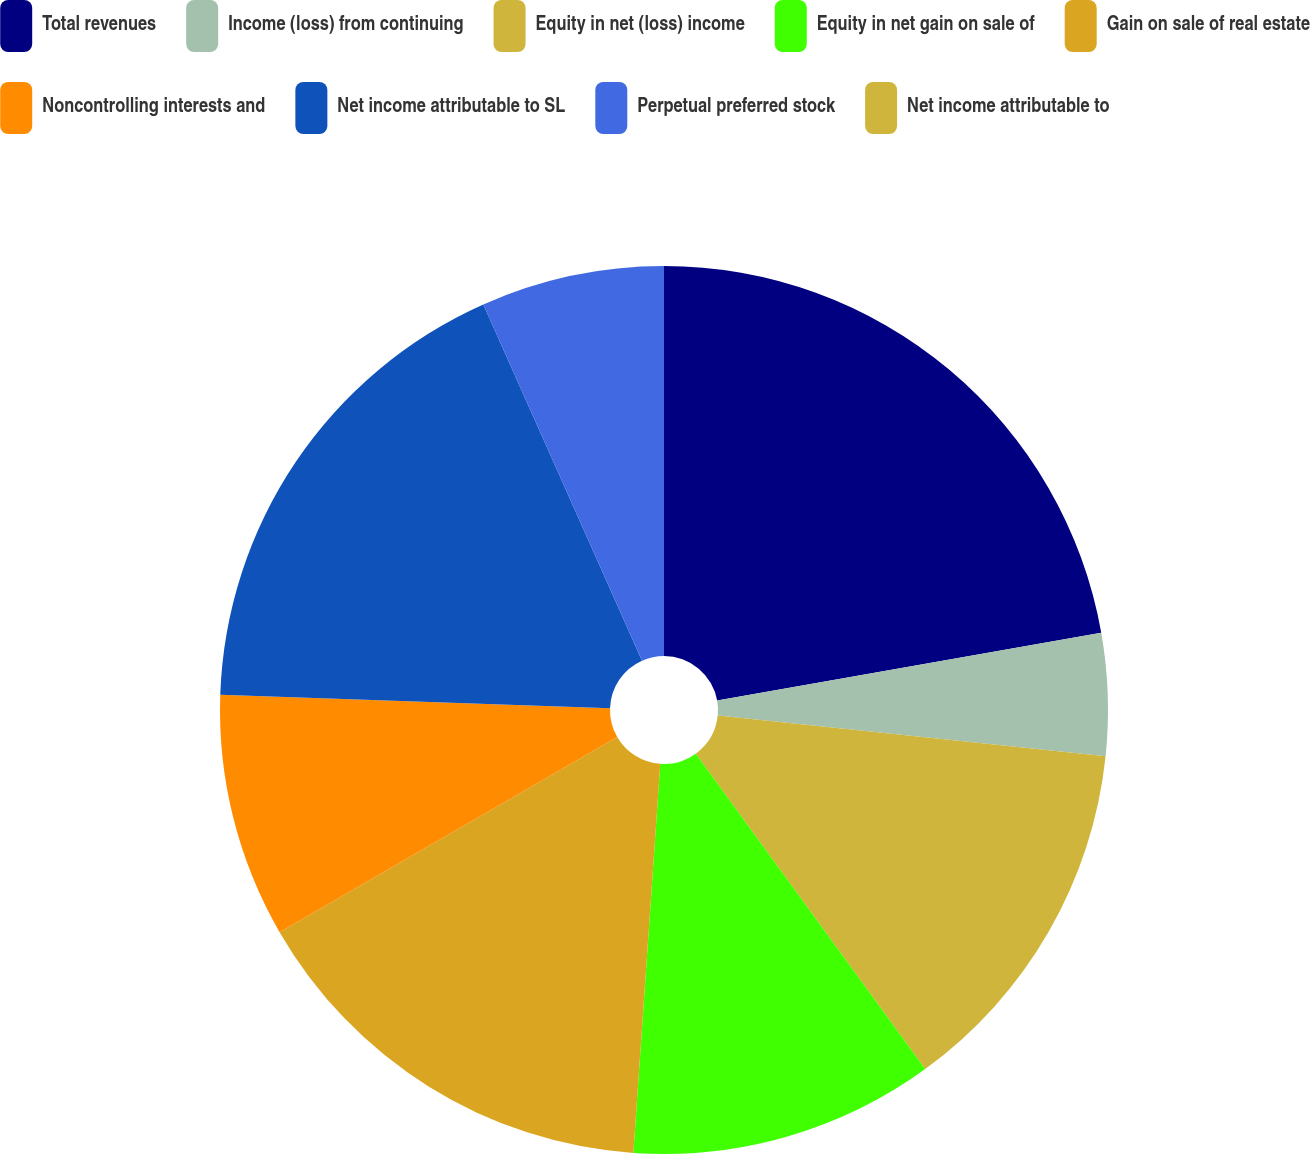<chart> <loc_0><loc_0><loc_500><loc_500><pie_chart><fcel>Total revenues<fcel>Income (loss) from continuing<fcel>Equity in net (loss) income<fcel>Equity in net gain on sale of<fcel>Gain on sale of real estate<fcel>Noncontrolling interests and<fcel>Net income attributable to SL<fcel>Perpetual preferred stock<fcel>Net income attributable to<nl><fcel>22.22%<fcel>4.44%<fcel>13.33%<fcel>11.11%<fcel>15.56%<fcel>8.89%<fcel>17.78%<fcel>6.67%<fcel>0.0%<nl></chart> 